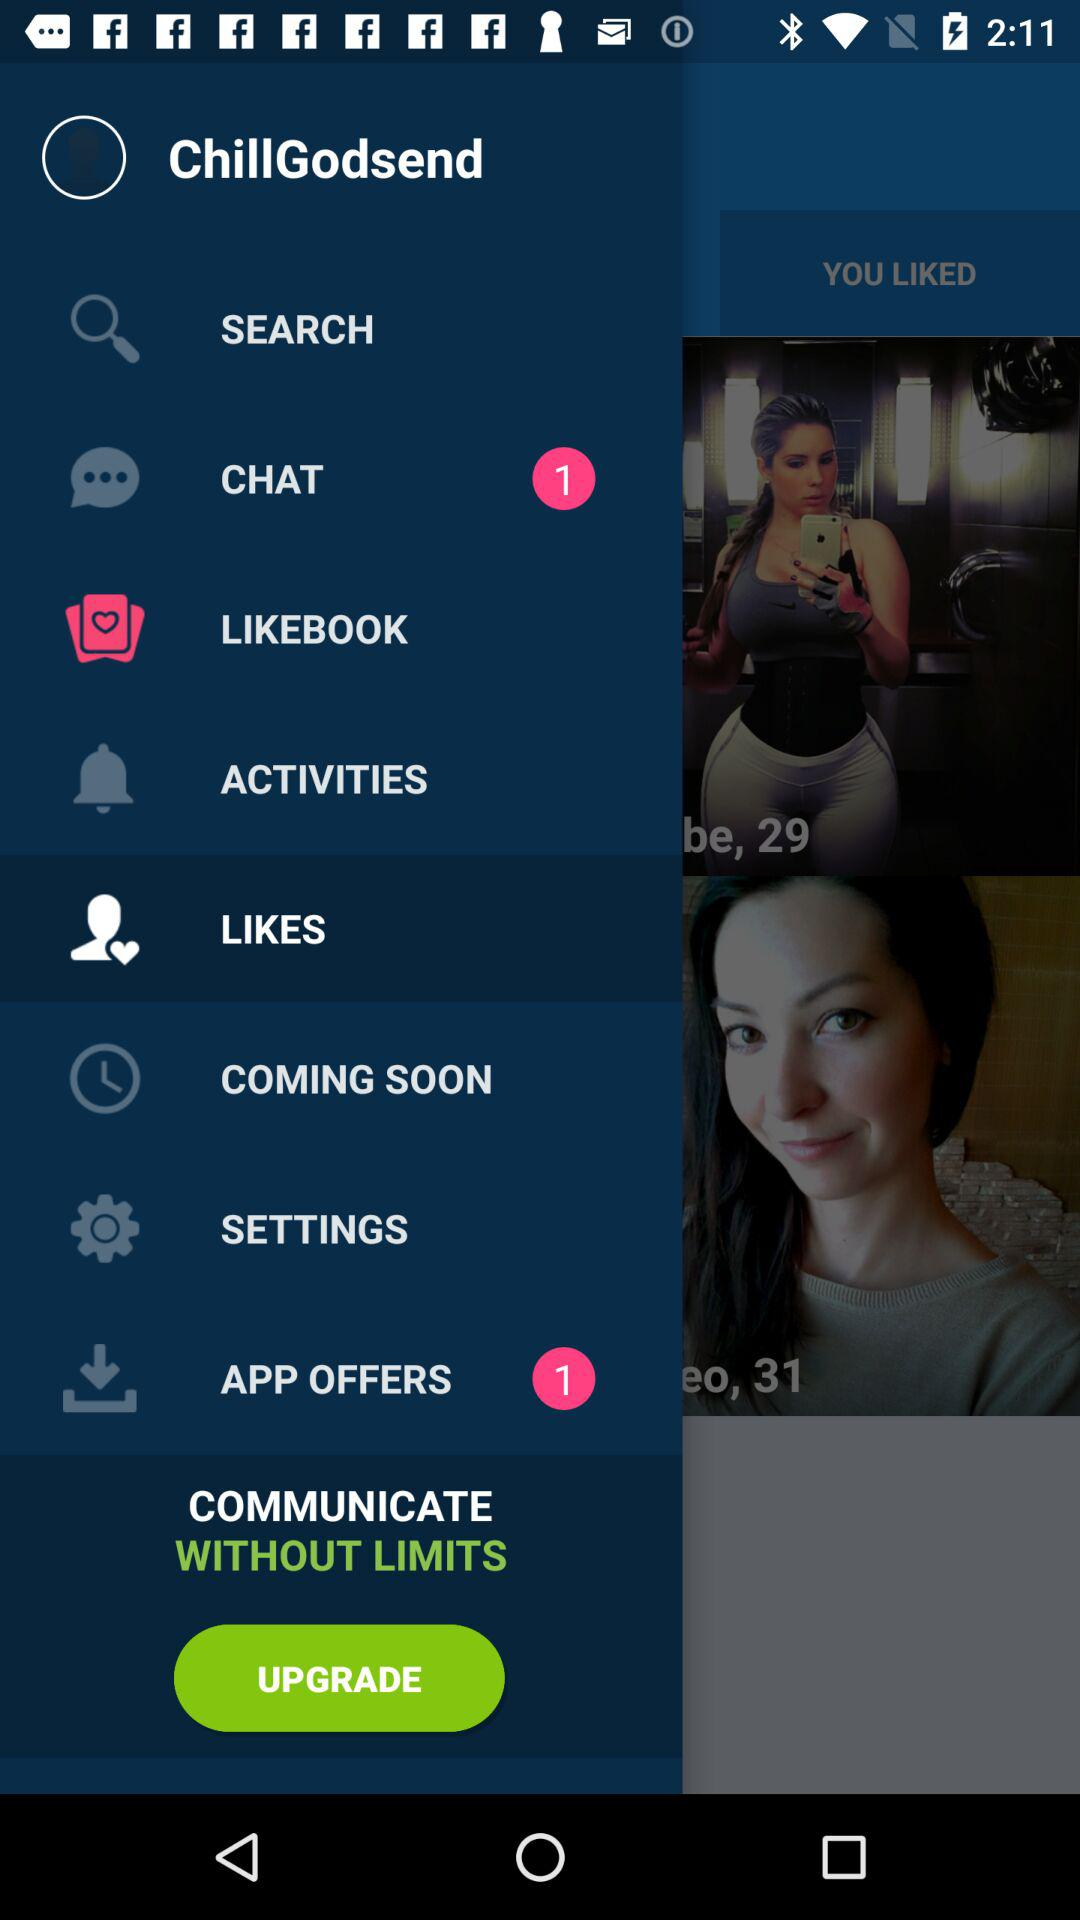Which option is selected? The selected option is "LIKES". 